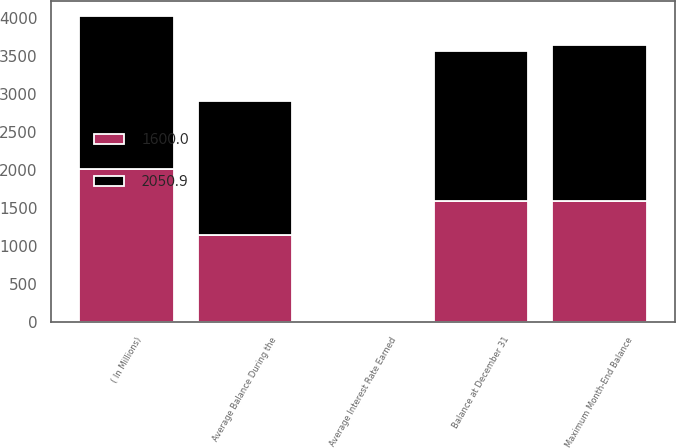Convert chart to OTSL. <chart><loc_0><loc_0><loc_500><loc_500><stacked_bar_chart><ecel><fcel>( In Millions)<fcel>Balance at December 31<fcel>Average Balance During the<fcel>Average Interest Rate Earned<fcel>Maximum Month-End Balance<nl><fcel>2050.9<fcel>2016<fcel>1967.5<fcel>1764.1<fcel>1.04<fcel>2050.9<nl><fcel>1600<fcel>2015<fcel>1600<fcel>1144.7<fcel>0.54<fcel>1600<nl></chart> 